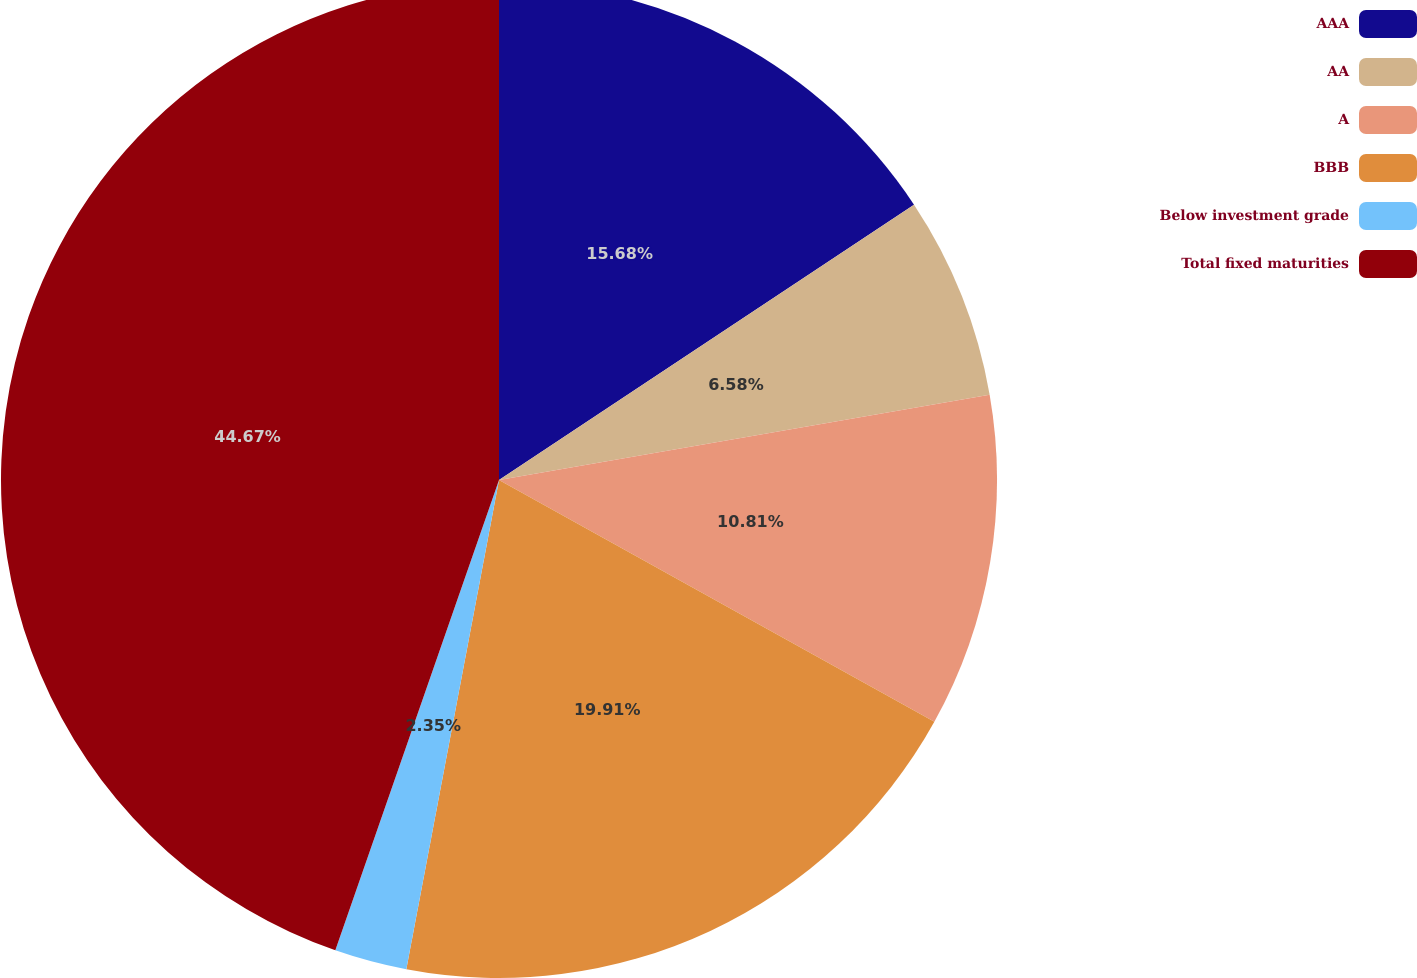Convert chart. <chart><loc_0><loc_0><loc_500><loc_500><pie_chart><fcel>AAA<fcel>AA<fcel>A<fcel>BBB<fcel>Below investment grade<fcel>Total fixed maturities<nl><fcel>15.68%<fcel>6.58%<fcel>10.81%<fcel>19.91%<fcel>2.35%<fcel>44.67%<nl></chart> 